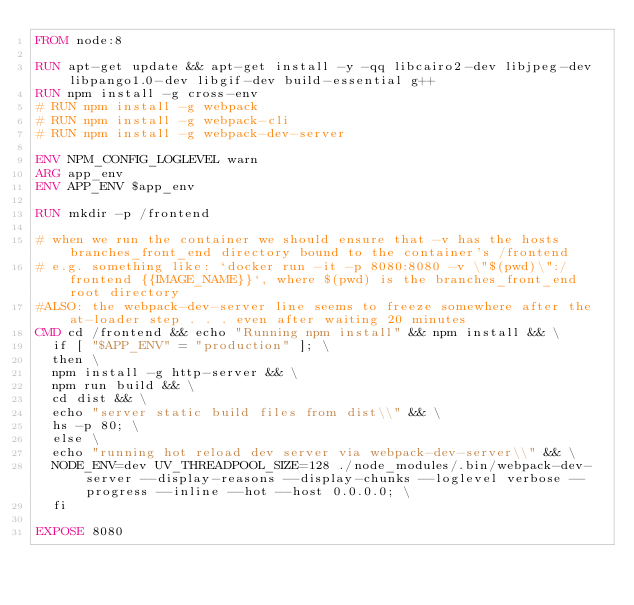Convert code to text. <code><loc_0><loc_0><loc_500><loc_500><_Dockerfile_>FROM node:8

RUN apt-get update && apt-get install -y -qq libcairo2-dev libjpeg-dev libpango1.0-dev libgif-dev build-essential g++
RUN npm install -g cross-env
# RUN npm install -g webpack
# RUN npm install -g webpack-cli
# RUN npm install -g webpack-dev-server

ENV NPM_CONFIG_LOGLEVEL warn
ARG app_env
ENV APP_ENV $app_env

RUN mkdir -p /frontend

# when we run the container we should ensure that -v has the hosts branches_front_end directory bound to the container's /frontend
# e.g. something like: `docker run -it -p 8080:8080 -v \"$(pwd)\":/frontend {{IMAGE_NAME}}`, where $(pwd) is the branches_front_end root directory
#ALSO: the webpack-dev-server line seems to freeze somewhere after the at-loader step . . . even after waiting 20 minutes
CMD cd /frontend && echo "Running npm install" && npm install && \
  if [ "$APP_ENV" = "production" ]; \
  then \
  npm install -g http-server && \
  npm run build && \
  cd dist && \
  echo "server static build files from dist\\" && \
  hs -p 80; \
  else \
  echo "running hot reload dev server via webpack-dev-server\\" && \
  NODE_ENV=dev UV_THREADPOOL_SIZE=128 ./node_modules/.bin/webpack-dev-server --display-reasons --display-chunks --loglevel verbose --progress --inline --hot --host 0.0.0.0; \
  fi

EXPOSE 8080
</code> 